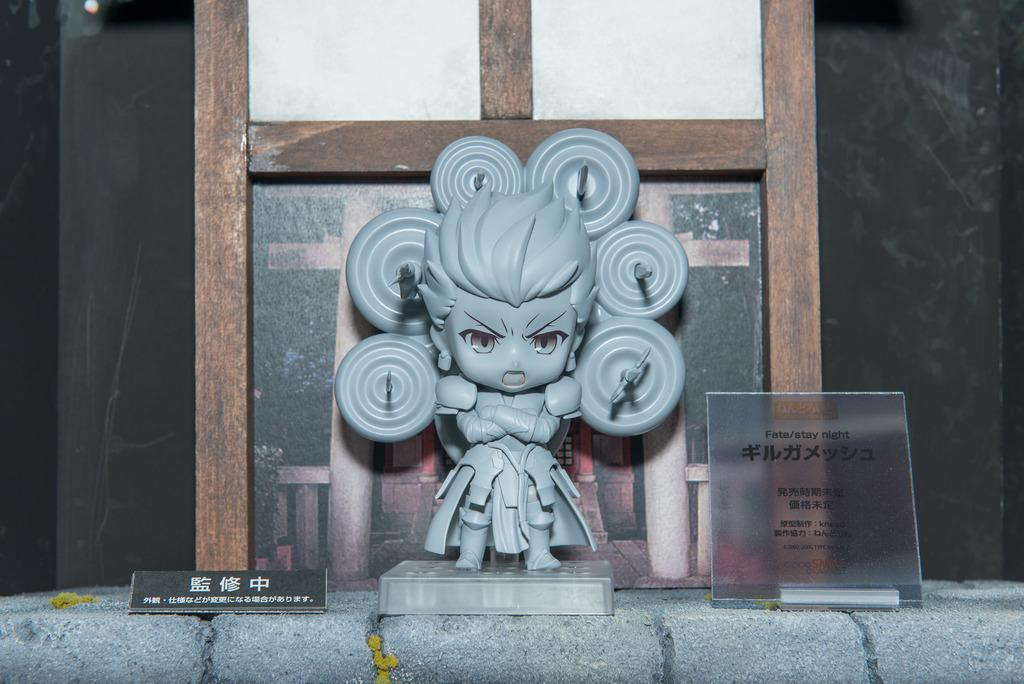What is the main object in the image? There is a pedestal in the image. What is attached to the pedestal? There is a frame in the image. What can be seen in the background of the image? There is a wall in the background of the image. What type of silk fabric is draped over the pedestal in the image? There is no silk fabric present in the image; only a pedestal and a frame are visible. 